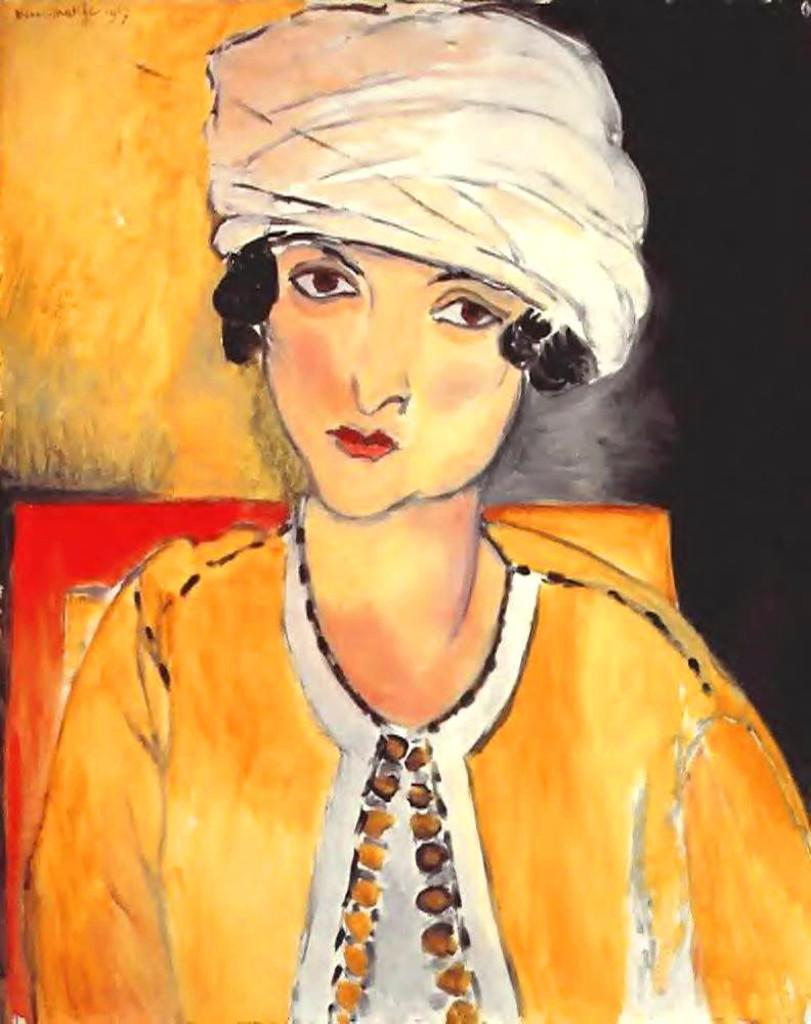What is the main subject of the painting? The painting depicts a person. What is the person wearing in the painting? The person is wearing a yellow colored dress and a turban on their head. What colors are present in the background of the painting? The background of the painting has yellow and black colors. Can you tell me how many clouds are in the painting? There are no clouds present in the painting; it features a person with a yellow dress and turban, and a yellow and black background. Are there any trees depicted in the painting? There are no trees depicted in the painting; it focuses on the person and the background colors. 